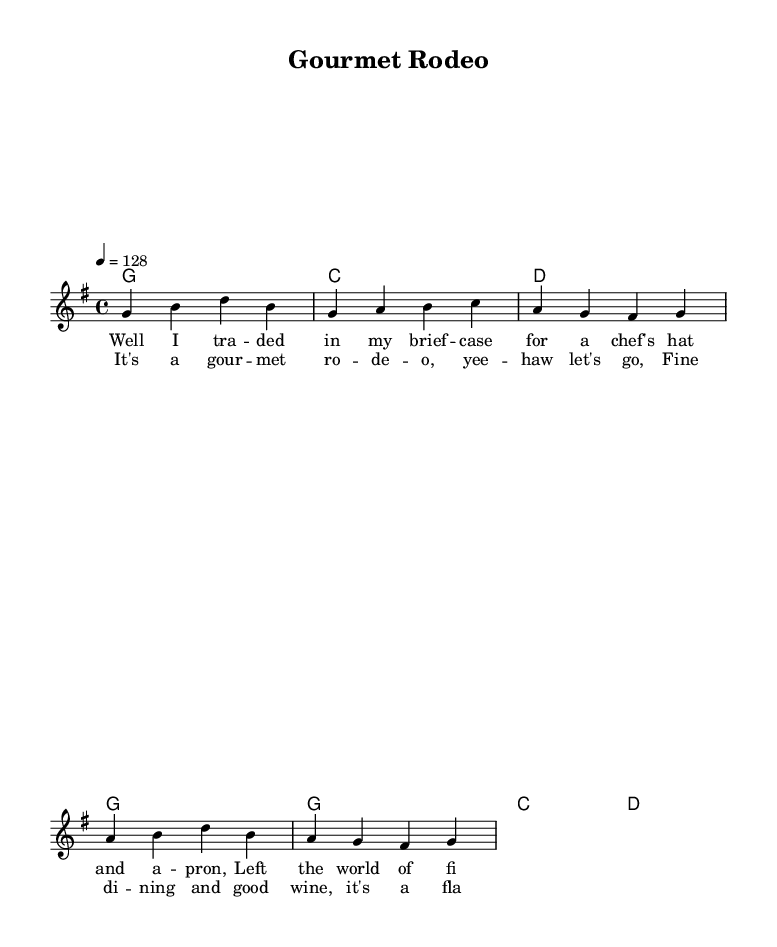What is the key signature of this music? The key signature is G major, which has one sharp (F#). This is identified by looking at the signature at the beginning of the staff.
Answer: G major What is the time signature of this piece? The time signature is 4/4, indicated at the beginning of the score. This means there are four beats in each measure, and the quarter note gets one beat.
Answer: 4/4 What is the tempo marking for this piece? The tempo is marked as '4 = 128', showing that there are 128 beats per minute. This information is stated right after the time signature at the beginning of the score.
Answer: 128 How many measures are there in the melody? The melody consists of 8 measures, as counted from the notations in the music. Each line typically represents two measures, and there are four lines in the melody section.
Answer: 8 What is the first word of the chorus lyrics? The first word of the chorus lyrics is "It's". This can be found by examining the lyrics that are written under the melody notes after the first verse.
Answer: It's What mood does the music likely convey? The music likely conveys an upbeat and celebratory mood. This can be inferred from the tempo and key signature, which are common in lively country rock songs celebrating experiences such as fine dining.
Answer: Upbeat How does the vocabulary in the lyrics relate to the theme of dining? The lyrics contain words like "gourmet" and "fine dining", emphasizing a culinary theme. These words specifically highlight the focus on food experiences, which aligns with the overall concept of the song.
Answer: Culinary theme 